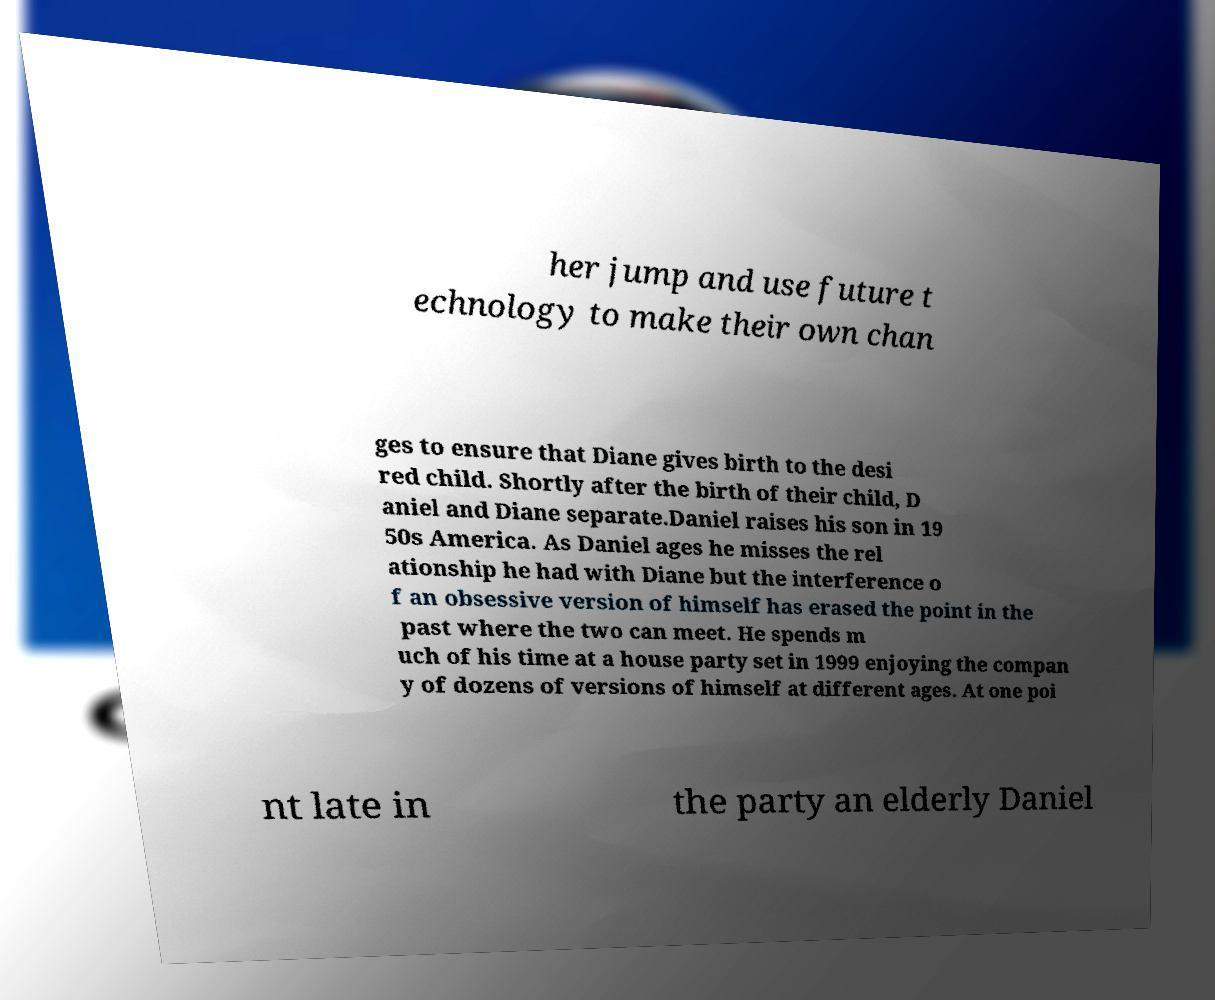What messages or text are displayed in this image? I need them in a readable, typed format. her jump and use future t echnology to make their own chan ges to ensure that Diane gives birth to the desi red child. Shortly after the birth of their child, D aniel and Diane separate.Daniel raises his son in 19 50s America. As Daniel ages he misses the rel ationship he had with Diane but the interference o f an obsessive version of himself has erased the point in the past where the two can meet. He spends m uch of his time at a house party set in 1999 enjoying the compan y of dozens of versions of himself at different ages. At one poi nt late in the party an elderly Daniel 